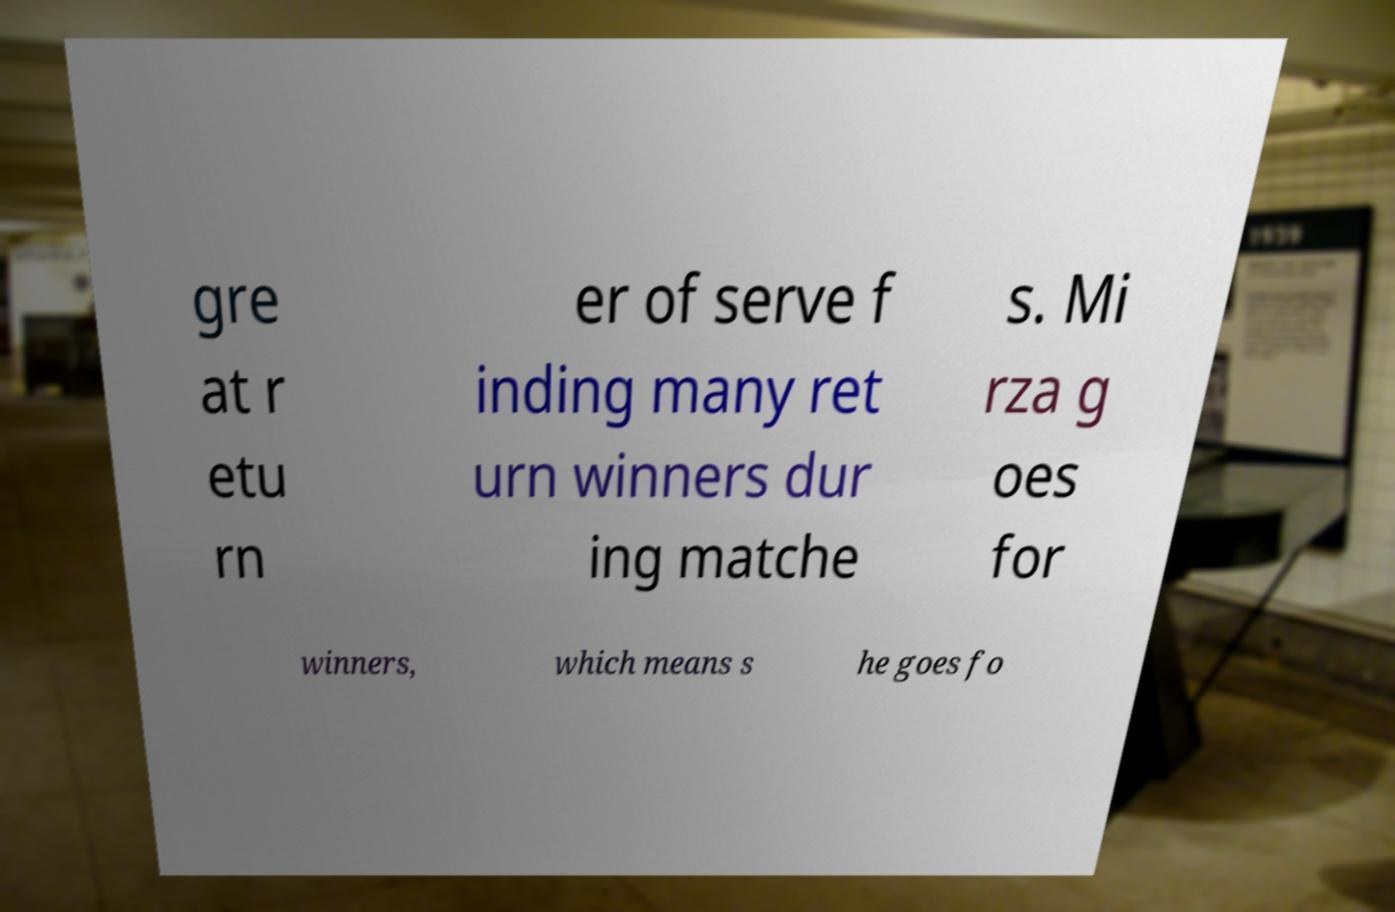What messages or text are displayed in this image? I need them in a readable, typed format. gre at r etu rn er of serve f inding many ret urn winners dur ing matche s. Mi rza g oes for winners, which means s he goes fo 